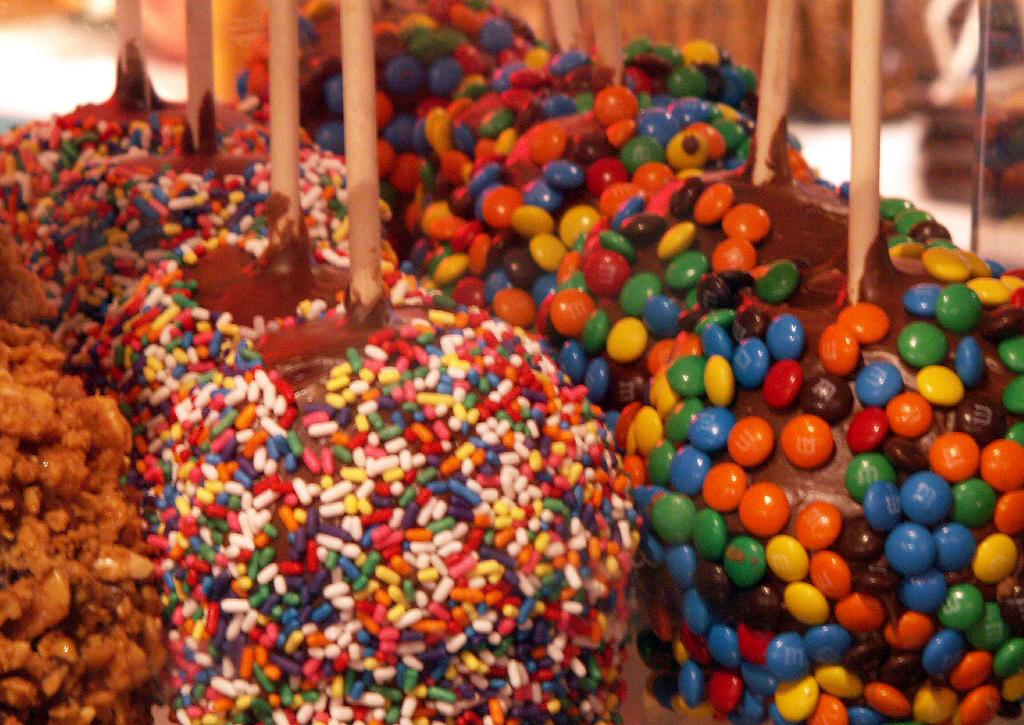What type of food is in the image? The image contains food with multiple colors. Can you describe the appearance of the food? The food has multiple colors, which makes it visually appealing. What else can be seen in the image besides the food? There are sticks visible in the image. What is the name of the daughter of the person who made the food in the image? There is no information about the person who made the food or their daughter in the image. How many bees can be seen flying around the food in the image? There are no bees present in the image. 